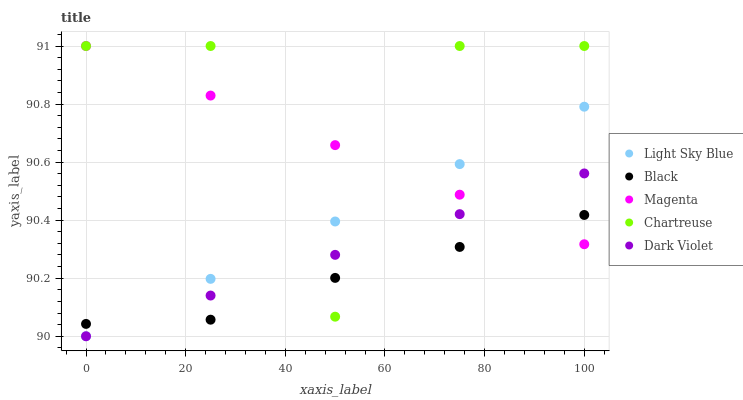Does Black have the minimum area under the curve?
Answer yes or no. Yes. Does Chartreuse have the maximum area under the curve?
Answer yes or no. Yes. Does Light Sky Blue have the minimum area under the curve?
Answer yes or no. No. Does Light Sky Blue have the maximum area under the curve?
Answer yes or no. No. Is Dark Violet the smoothest?
Answer yes or no. Yes. Is Chartreuse the roughest?
Answer yes or no. Yes. Is Light Sky Blue the smoothest?
Answer yes or no. No. Is Light Sky Blue the roughest?
Answer yes or no. No. Does Light Sky Blue have the lowest value?
Answer yes or no. Yes. Does Black have the lowest value?
Answer yes or no. No. Does Chartreuse have the highest value?
Answer yes or no. Yes. Does Light Sky Blue have the highest value?
Answer yes or no. No. Does Black intersect Chartreuse?
Answer yes or no. Yes. Is Black less than Chartreuse?
Answer yes or no. No. Is Black greater than Chartreuse?
Answer yes or no. No. 